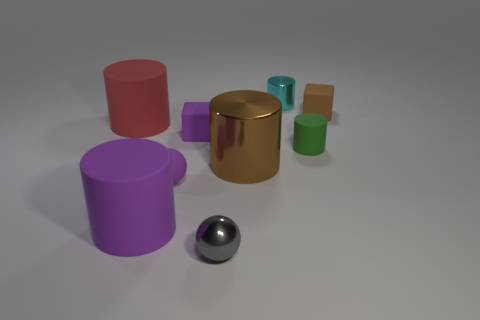Add 1 small purple shiny cylinders. How many objects exist? 10 Subtract all purple cylinders. How many cylinders are left? 4 Subtract all purple cubes. How many cubes are left? 1 Subtract 4 cylinders. How many cylinders are left? 1 Add 3 tiny purple matte objects. How many tiny purple matte objects are left? 5 Add 7 small cyan metallic cylinders. How many small cyan metallic cylinders exist? 8 Subtract 1 purple balls. How many objects are left? 8 Subtract all cubes. How many objects are left? 7 Subtract all green spheres. Subtract all purple blocks. How many spheres are left? 2 Subtract all cyan cylinders. How many purple blocks are left? 1 